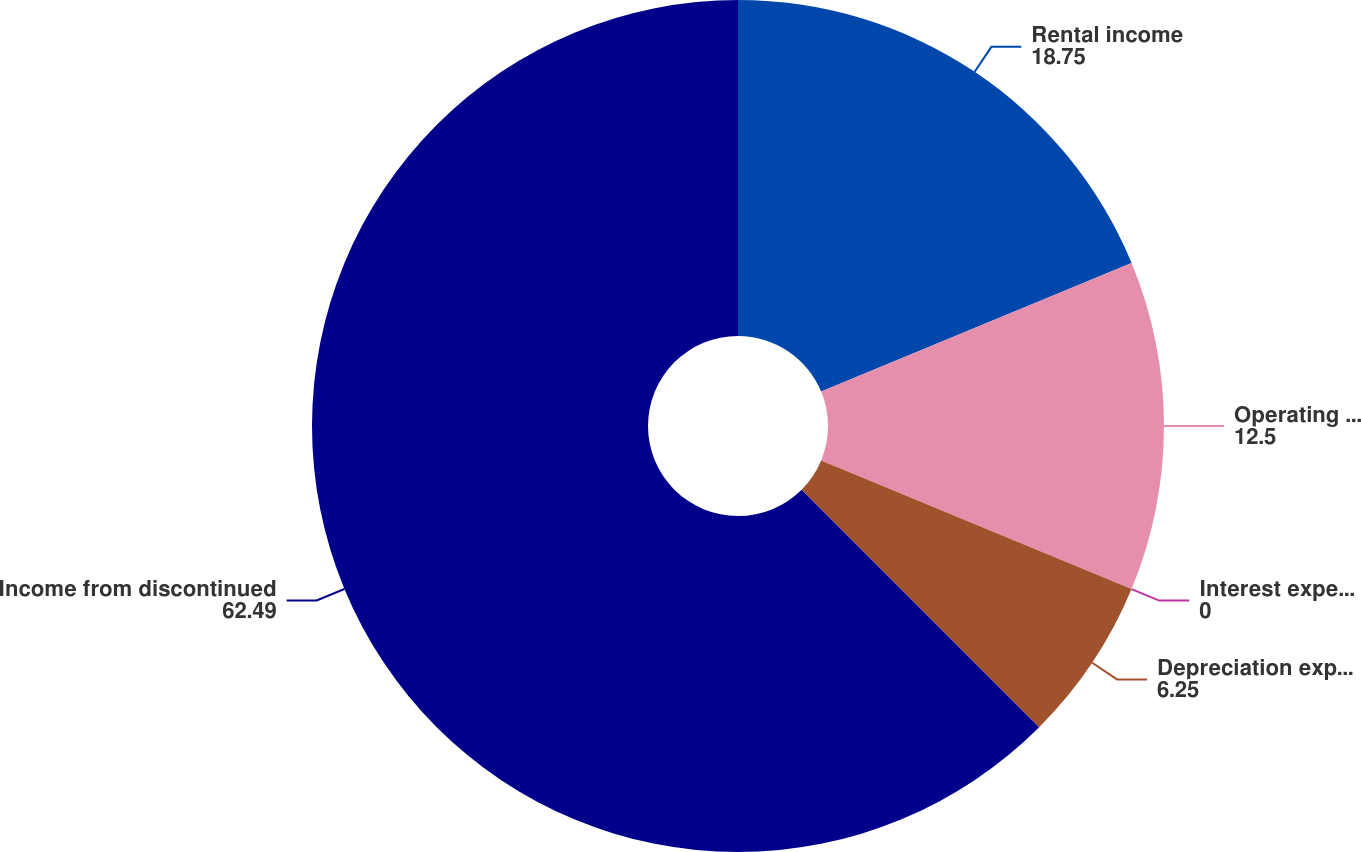Convert chart to OTSL. <chart><loc_0><loc_0><loc_500><loc_500><pie_chart><fcel>Rental income<fcel>Operating and other expenses<fcel>Interest expense net<fcel>Depreciation expense<fcel>Income from discontinued<nl><fcel>18.75%<fcel>12.5%<fcel>0.0%<fcel>6.25%<fcel>62.49%<nl></chart> 